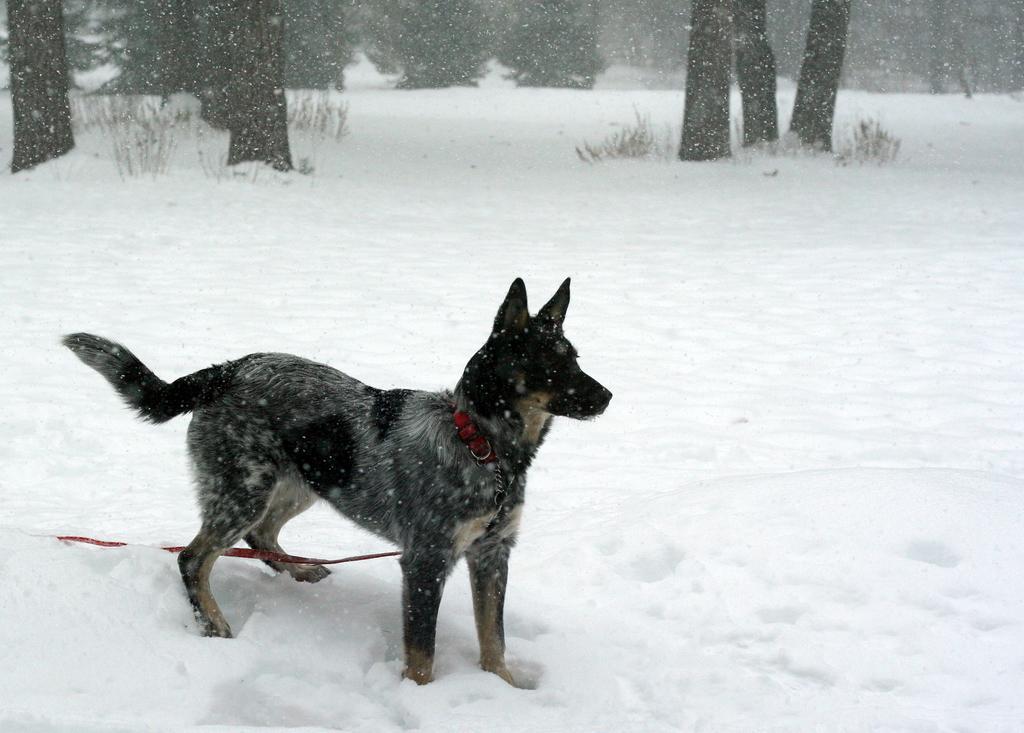Describe this image in one or two sentences. In this image I can see a dog which is black and brown color. We can see snow and trees. 